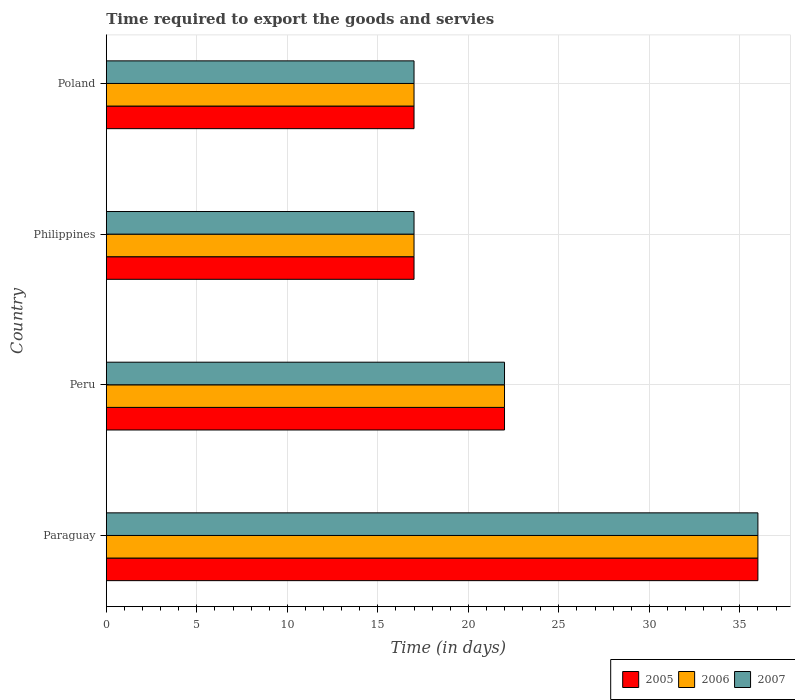What is the label of the 3rd group of bars from the top?
Provide a succinct answer. Peru. Across all countries, what is the minimum number of days required to export the goods and services in 2005?
Give a very brief answer. 17. In which country was the number of days required to export the goods and services in 2007 maximum?
Make the answer very short. Paraguay. What is the total number of days required to export the goods and services in 2007 in the graph?
Make the answer very short. 92. What is the difference between the number of days required to export the goods and services in 2005 in Philippines and that in Poland?
Ensure brevity in your answer.  0. What is the difference between the number of days required to export the goods and services in 2005 in Peru and the number of days required to export the goods and services in 2006 in Philippines?
Your answer should be very brief. 5. In how many countries, is the number of days required to export the goods and services in 2007 greater than 14 days?
Your answer should be compact. 4. What is the ratio of the number of days required to export the goods and services in 2005 in Peru to that in Philippines?
Make the answer very short. 1.29. What is the difference between the highest and the lowest number of days required to export the goods and services in 2005?
Make the answer very short. 19. In how many countries, is the number of days required to export the goods and services in 2007 greater than the average number of days required to export the goods and services in 2007 taken over all countries?
Keep it short and to the point. 1. What does the 2nd bar from the bottom in Paraguay represents?
Provide a short and direct response. 2006. Is it the case that in every country, the sum of the number of days required to export the goods and services in 2005 and number of days required to export the goods and services in 2007 is greater than the number of days required to export the goods and services in 2006?
Offer a terse response. Yes. How many bars are there?
Provide a short and direct response. 12. What is the difference between two consecutive major ticks on the X-axis?
Ensure brevity in your answer.  5. Does the graph contain any zero values?
Keep it short and to the point. No. Does the graph contain grids?
Offer a terse response. Yes. What is the title of the graph?
Provide a short and direct response. Time required to export the goods and servies. Does "1983" appear as one of the legend labels in the graph?
Offer a terse response. No. What is the label or title of the X-axis?
Your response must be concise. Time (in days). What is the Time (in days) in 2005 in Paraguay?
Give a very brief answer. 36. What is the Time (in days) in 2007 in Paraguay?
Your response must be concise. 36. What is the Time (in days) of 2005 in Peru?
Provide a short and direct response. 22. What is the Time (in days) of 2007 in Peru?
Offer a terse response. 22. What is the Time (in days) of 2005 in Philippines?
Provide a short and direct response. 17. What is the Time (in days) of 2006 in Philippines?
Provide a short and direct response. 17. What is the Time (in days) of 2007 in Philippines?
Provide a succinct answer. 17. What is the Time (in days) in 2007 in Poland?
Make the answer very short. 17. Across all countries, what is the maximum Time (in days) of 2005?
Your answer should be very brief. 36. Across all countries, what is the minimum Time (in days) of 2005?
Provide a succinct answer. 17. Across all countries, what is the minimum Time (in days) in 2007?
Offer a very short reply. 17. What is the total Time (in days) of 2005 in the graph?
Offer a very short reply. 92. What is the total Time (in days) in 2006 in the graph?
Your answer should be compact. 92. What is the total Time (in days) in 2007 in the graph?
Offer a terse response. 92. What is the difference between the Time (in days) of 2005 in Paraguay and that in Peru?
Provide a succinct answer. 14. What is the difference between the Time (in days) in 2006 in Paraguay and that in Peru?
Your answer should be compact. 14. What is the difference between the Time (in days) of 2007 in Paraguay and that in Peru?
Your answer should be compact. 14. What is the difference between the Time (in days) in 2006 in Paraguay and that in Philippines?
Ensure brevity in your answer.  19. What is the difference between the Time (in days) of 2007 in Paraguay and that in Philippines?
Keep it short and to the point. 19. What is the difference between the Time (in days) in 2005 in Paraguay and that in Poland?
Your answer should be very brief. 19. What is the difference between the Time (in days) of 2006 in Paraguay and that in Poland?
Offer a very short reply. 19. What is the difference between the Time (in days) of 2007 in Paraguay and that in Poland?
Provide a short and direct response. 19. What is the difference between the Time (in days) of 2005 in Peru and that in Philippines?
Your answer should be very brief. 5. What is the difference between the Time (in days) of 2006 in Peru and that in Philippines?
Your response must be concise. 5. What is the difference between the Time (in days) of 2006 in Peru and that in Poland?
Give a very brief answer. 5. What is the difference between the Time (in days) in 2007 in Philippines and that in Poland?
Your answer should be very brief. 0. What is the difference between the Time (in days) of 2005 in Paraguay and the Time (in days) of 2006 in Peru?
Provide a succinct answer. 14. What is the difference between the Time (in days) of 2006 in Paraguay and the Time (in days) of 2007 in Peru?
Provide a short and direct response. 14. What is the difference between the Time (in days) in 2005 in Paraguay and the Time (in days) in 2007 in Philippines?
Your answer should be compact. 19. What is the difference between the Time (in days) of 2006 in Paraguay and the Time (in days) of 2007 in Philippines?
Make the answer very short. 19. What is the difference between the Time (in days) in 2005 in Paraguay and the Time (in days) in 2006 in Poland?
Ensure brevity in your answer.  19. What is the difference between the Time (in days) of 2005 in Paraguay and the Time (in days) of 2007 in Poland?
Provide a succinct answer. 19. What is the difference between the Time (in days) in 2006 in Paraguay and the Time (in days) in 2007 in Poland?
Keep it short and to the point. 19. What is the difference between the Time (in days) of 2005 in Peru and the Time (in days) of 2007 in Philippines?
Your answer should be very brief. 5. What is the difference between the Time (in days) of 2005 in Peru and the Time (in days) of 2006 in Poland?
Make the answer very short. 5. What is the difference between the Time (in days) in 2006 in Philippines and the Time (in days) in 2007 in Poland?
Offer a terse response. 0. What is the average Time (in days) in 2005 per country?
Your answer should be very brief. 23. What is the average Time (in days) of 2007 per country?
Your answer should be very brief. 23. What is the difference between the Time (in days) in 2005 and Time (in days) in 2006 in Paraguay?
Ensure brevity in your answer.  0. What is the difference between the Time (in days) of 2006 and Time (in days) of 2007 in Paraguay?
Your answer should be very brief. 0. What is the difference between the Time (in days) in 2005 and Time (in days) in 2007 in Peru?
Your response must be concise. 0. What is the difference between the Time (in days) of 2006 and Time (in days) of 2007 in Peru?
Your answer should be compact. 0. What is the difference between the Time (in days) in 2005 and Time (in days) in 2007 in Philippines?
Your answer should be compact. 0. What is the difference between the Time (in days) in 2005 and Time (in days) in 2007 in Poland?
Offer a terse response. 0. What is the ratio of the Time (in days) of 2005 in Paraguay to that in Peru?
Give a very brief answer. 1.64. What is the ratio of the Time (in days) in 2006 in Paraguay to that in Peru?
Make the answer very short. 1.64. What is the ratio of the Time (in days) of 2007 in Paraguay to that in Peru?
Ensure brevity in your answer.  1.64. What is the ratio of the Time (in days) in 2005 in Paraguay to that in Philippines?
Provide a succinct answer. 2.12. What is the ratio of the Time (in days) of 2006 in Paraguay to that in Philippines?
Your answer should be compact. 2.12. What is the ratio of the Time (in days) in 2007 in Paraguay to that in Philippines?
Your answer should be very brief. 2.12. What is the ratio of the Time (in days) in 2005 in Paraguay to that in Poland?
Offer a terse response. 2.12. What is the ratio of the Time (in days) in 2006 in Paraguay to that in Poland?
Provide a succinct answer. 2.12. What is the ratio of the Time (in days) in 2007 in Paraguay to that in Poland?
Your answer should be compact. 2.12. What is the ratio of the Time (in days) of 2005 in Peru to that in Philippines?
Provide a short and direct response. 1.29. What is the ratio of the Time (in days) in 2006 in Peru to that in Philippines?
Your answer should be compact. 1.29. What is the ratio of the Time (in days) in 2007 in Peru to that in Philippines?
Ensure brevity in your answer.  1.29. What is the ratio of the Time (in days) of 2005 in Peru to that in Poland?
Your answer should be very brief. 1.29. What is the ratio of the Time (in days) in 2006 in Peru to that in Poland?
Provide a short and direct response. 1.29. What is the ratio of the Time (in days) of 2007 in Peru to that in Poland?
Your answer should be very brief. 1.29. What is the ratio of the Time (in days) of 2006 in Philippines to that in Poland?
Your answer should be very brief. 1. What is the ratio of the Time (in days) of 2007 in Philippines to that in Poland?
Provide a succinct answer. 1. What is the difference between the highest and the second highest Time (in days) in 2005?
Your response must be concise. 14. What is the difference between the highest and the second highest Time (in days) in 2006?
Give a very brief answer. 14. What is the difference between the highest and the second highest Time (in days) of 2007?
Your answer should be very brief. 14. What is the difference between the highest and the lowest Time (in days) in 2006?
Your response must be concise. 19. What is the difference between the highest and the lowest Time (in days) in 2007?
Your answer should be compact. 19. 